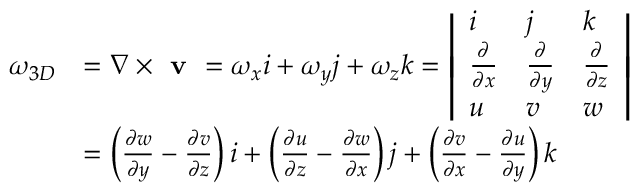<formula> <loc_0><loc_0><loc_500><loc_500>\begin{array} { r l } { \omega _ { 3 D } } & { = \nabla \times v = \omega _ { x } i + \omega _ { y } j + \omega _ { z } k = \left | \begin{array} { l l l } { i } & { j } & { k } \\ { \frac { \partial } { \partial x } } & { \frac { \partial } { \partial y } } & { \frac { \partial } { \partial z } } \\ { u } & { v } & { w } \end{array} \right | } \\ & { = \left ( { \frac { \partial w } { \partial y } - \frac { \partial v } { \partial z } } \right ) i + \left ( { \frac { \partial u } { \partial z } - \frac { \partial w } { \partial x } } \right ) j + \left ( { \frac { \partial v } { \partial x } - \frac { \partial u } { \partial y } } \right ) k } \end{array}</formula> 